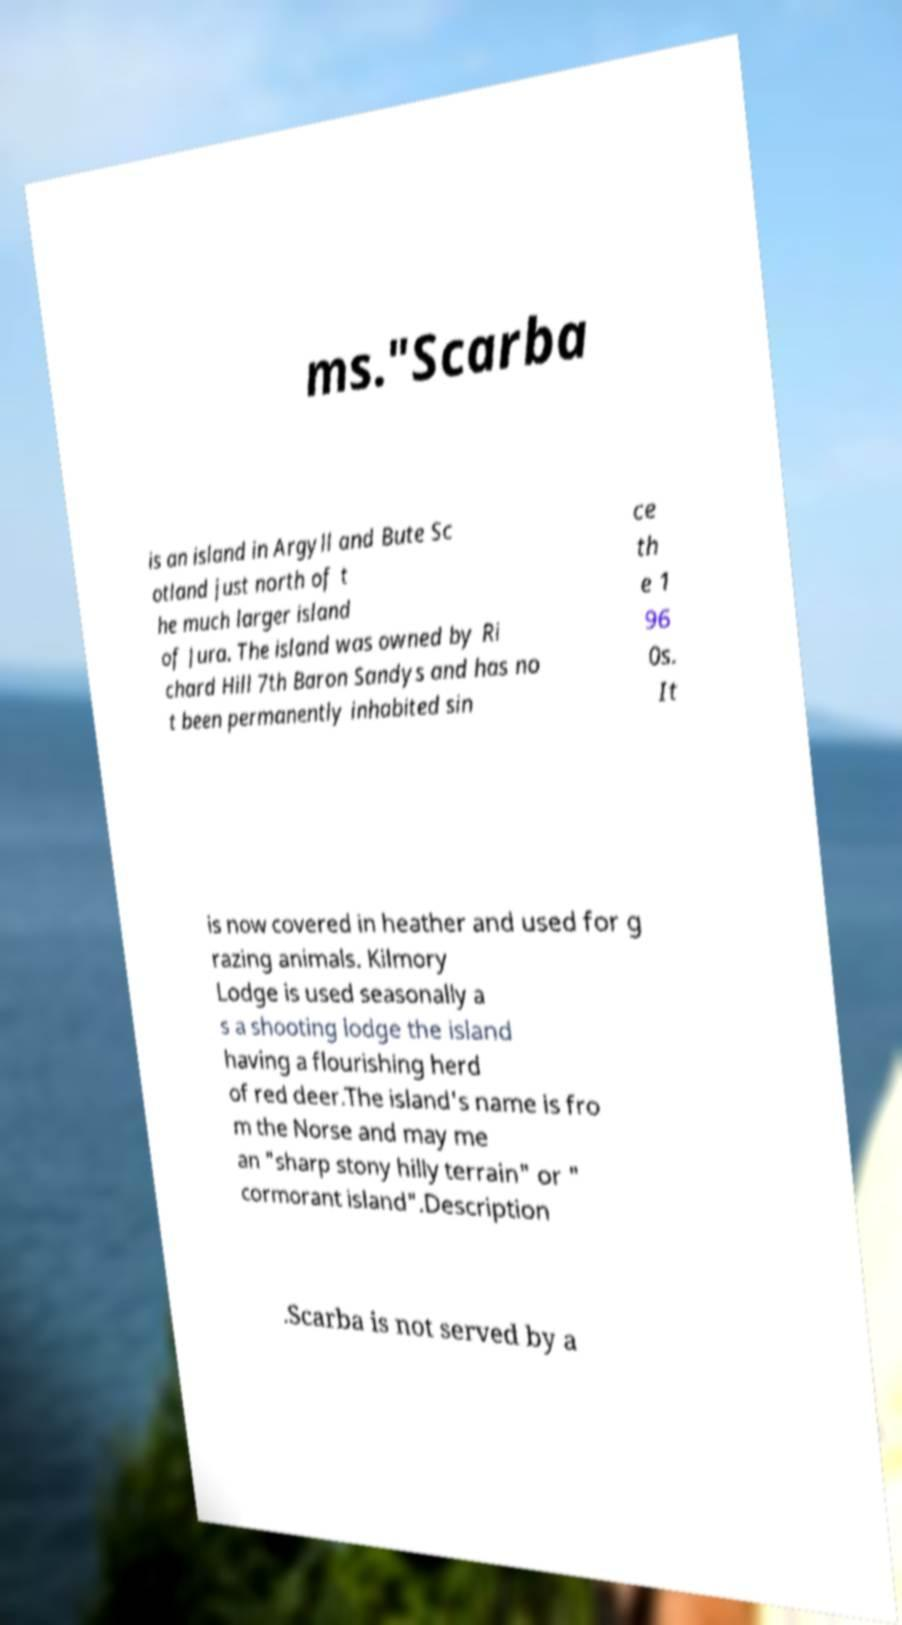Please read and relay the text visible in this image. What does it say? ms."Scarba is an island in Argyll and Bute Sc otland just north of t he much larger island of Jura. The island was owned by Ri chard Hill 7th Baron Sandys and has no t been permanently inhabited sin ce th e 1 96 0s. It is now covered in heather and used for g razing animals. Kilmory Lodge is used seasonally a s a shooting lodge the island having a flourishing herd of red deer.The island's name is fro m the Norse and may me an "sharp stony hilly terrain" or " cormorant island".Description .Scarba is not served by a 